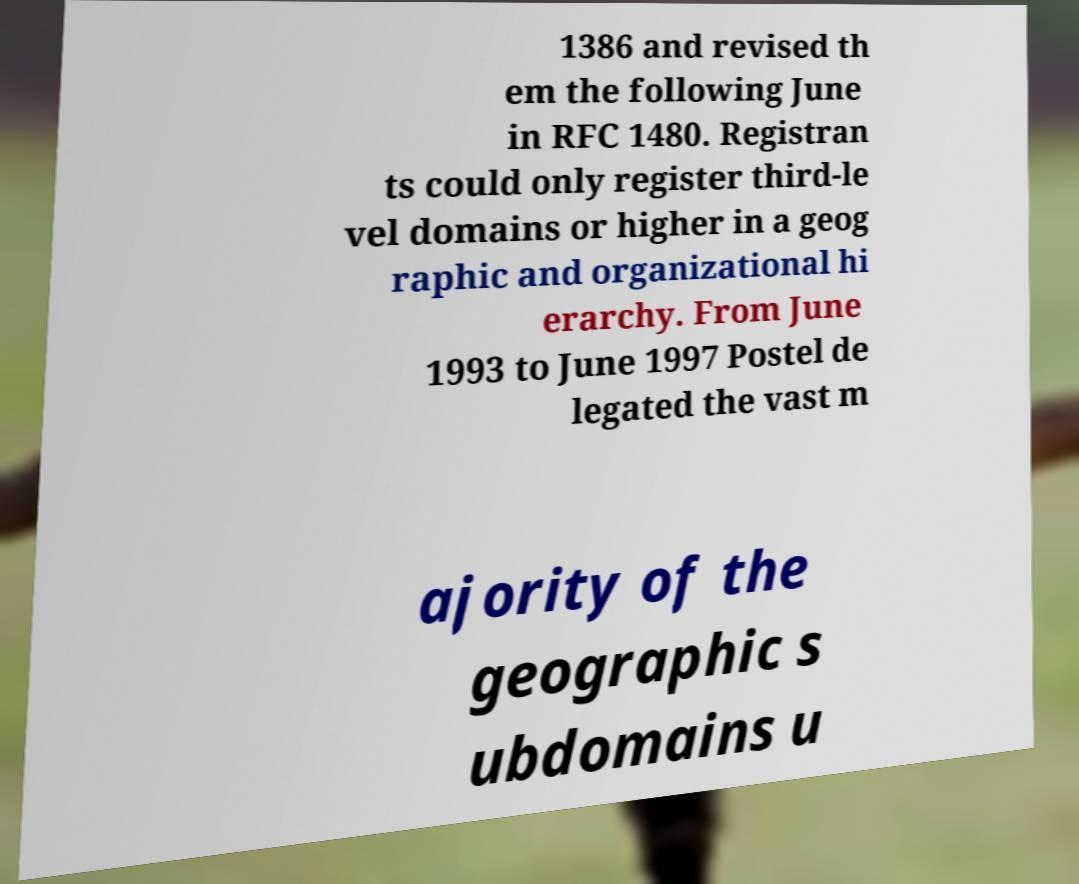Could you extract and type out the text from this image? 1386 and revised th em the following June in RFC 1480. Registran ts could only register third-le vel domains or higher in a geog raphic and organizational hi erarchy. From June 1993 to June 1997 Postel de legated the vast m ajority of the geographic s ubdomains u 